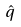Convert formula to latex. <formula><loc_0><loc_0><loc_500><loc_500>\hat { q }</formula> 